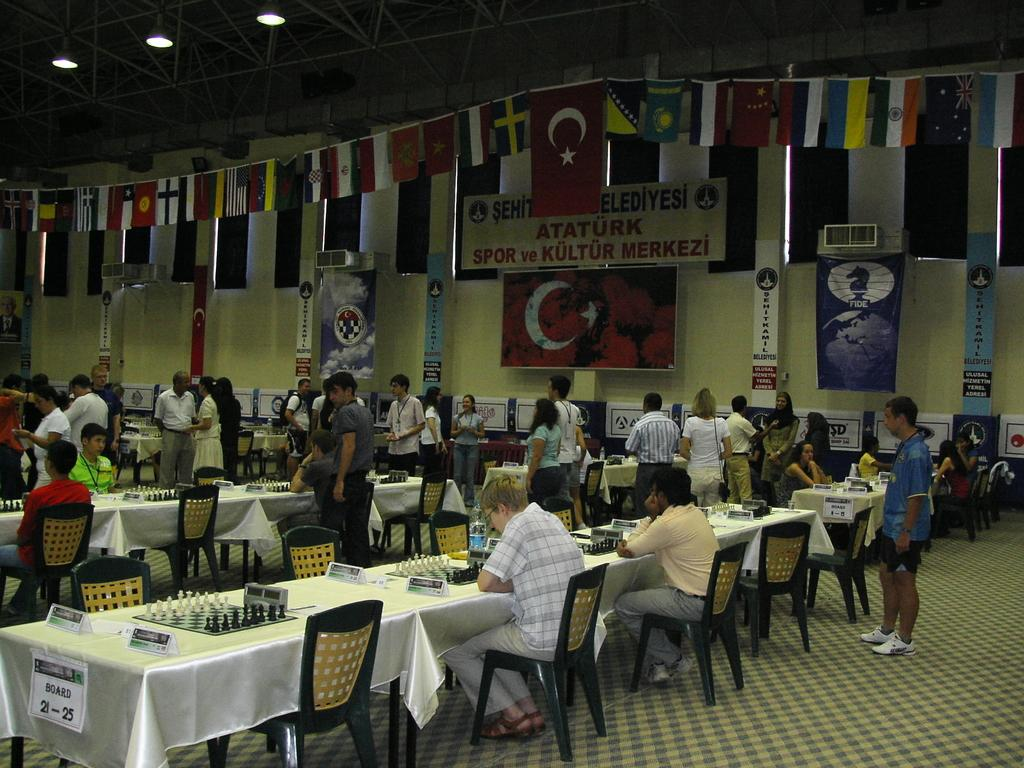What are the people in the image doing? Some people are sitting, and some people are standing. Can you describe the positions of the people in the image? Yes, some people are sitting, and some people are standing. What can be seen in the background of the image? There are flags of different countries in the background. What type of plants can be seen growing on the slope in the image? There is no slope or plants present in the image. 